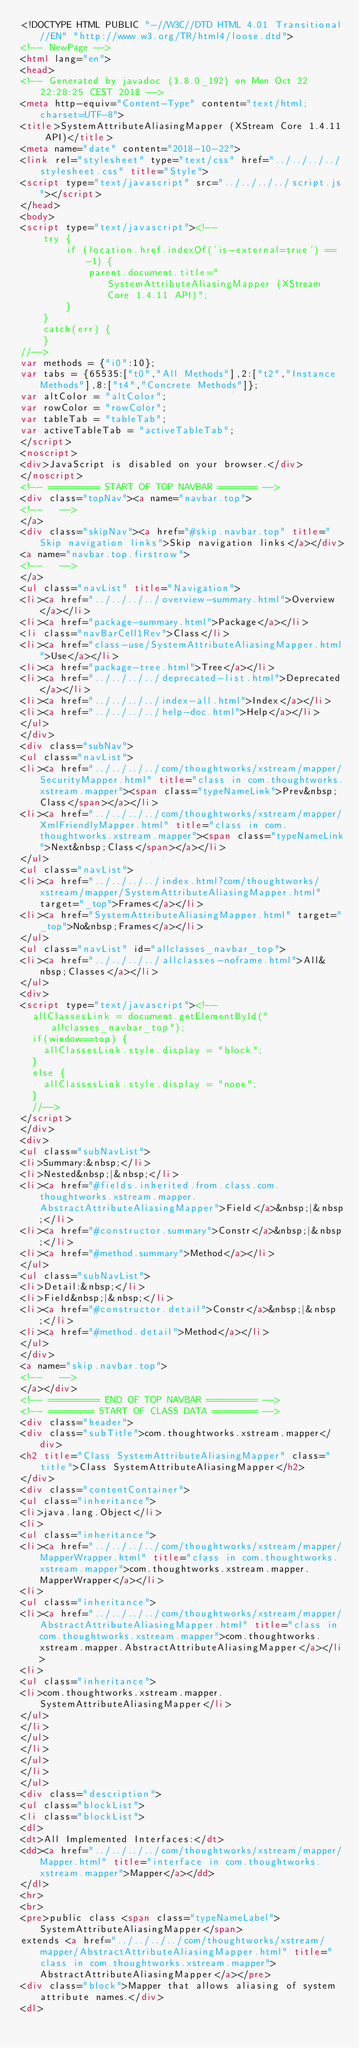<code> <loc_0><loc_0><loc_500><loc_500><_HTML_><!DOCTYPE HTML PUBLIC "-//W3C//DTD HTML 4.01 Transitional//EN" "http://www.w3.org/TR/html4/loose.dtd">
<!-- NewPage -->
<html lang="en">
<head>
<!-- Generated by javadoc (1.8.0_192) on Mon Oct 22 22:28:25 CEST 2018 -->
<meta http-equiv="Content-Type" content="text/html; charset=UTF-8">
<title>SystemAttributeAliasingMapper (XStream Core 1.4.11 API)</title>
<meta name="date" content="2018-10-22">
<link rel="stylesheet" type="text/css" href="../../../../stylesheet.css" title="Style">
<script type="text/javascript" src="../../../../script.js"></script>
</head>
<body>
<script type="text/javascript"><!--
    try {
        if (location.href.indexOf('is-external=true') == -1) {
            parent.document.title="SystemAttributeAliasingMapper (XStream Core 1.4.11 API)";
        }
    }
    catch(err) {
    }
//-->
var methods = {"i0":10};
var tabs = {65535:["t0","All Methods"],2:["t2","Instance Methods"],8:["t4","Concrete Methods"]};
var altColor = "altColor";
var rowColor = "rowColor";
var tableTab = "tableTab";
var activeTableTab = "activeTableTab";
</script>
<noscript>
<div>JavaScript is disabled on your browser.</div>
</noscript>
<!-- ========= START OF TOP NAVBAR ======= -->
<div class="topNav"><a name="navbar.top">
<!--   -->
</a>
<div class="skipNav"><a href="#skip.navbar.top" title="Skip navigation links">Skip navigation links</a></div>
<a name="navbar.top.firstrow">
<!--   -->
</a>
<ul class="navList" title="Navigation">
<li><a href="../../../../overview-summary.html">Overview</a></li>
<li><a href="package-summary.html">Package</a></li>
<li class="navBarCell1Rev">Class</li>
<li><a href="class-use/SystemAttributeAliasingMapper.html">Use</a></li>
<li><a href="package-tree.html">Tree</a></li>
<li><a href="../../../../deprecated-list.html">Deprecated</a></li>
<li><a href="../../../../index-all.html">Index</a></li>
<li><a href="../../../../help-doc.html">Help</a></li>
</ul>
</div>
<div class="subNav">
<ul class="navList">
<li><a href="../../../../com/thoughtworks/xstream/mapper/SecurityMapper.html" title="class in com.thoughtworks.xstream.mapper"><span class="typeNameLink">Prev&nbsp;Class</span></a></li>
<li><a href="../../../../com/thoughtworks/xstream/mapper/XmlFriendlyMapper.html" title="class in com.thoughtworks.xstream.mapper"><span class="typeNameLink">Next&nbsp;Class</span></a></li>
</ul>
<ul class="navList">
<li><a href="../../../../index.html?com/thoughtworks/xstream/mapper/SystemAttributeAliasingMapper.html" target="_top">Frames</a></li>
<li><a href="SystemAttributeAliasingMapper.html" target="_top">No&nbsp;Frames</a></li>
</ul>
<ul class="navList" id="allclasses_navbar_top">
<li><a href="../../../../allclasses-noframe.html">All&nbsp;Classes</a></li>
</ul>
<div>
<script type="text/javascript"><!--
  allClassesLink = document.getElementById("allclasses_navbar_top");
  if(window==top) {
    allClassesLink.style.display = "block";
  }
  else {
    allClassesLink.style.display = "none";
  }
  //-->
</script>
</div>
<div>
<ul class="subNavList">
<li>Summary:&nbsp;</li>
<li>Nested&nbsp;|&nbsp;</li>
<li><a href="#fields.inherited.from.class.com.thoughtworks.xstream.mapper.AbstractAttributeAliasingMapper">Field</a>&nbsp;|&nbsp;</li>
<li><a href="#constructor.summary">Constr</a>&nbsp;|&nbsp;</li>
<li><a href="#method.summary">Method</a></li>
</ul>
<ul class="subNavList">
<li>Detail:&nbsp;</li>
<li>Field&nbsp;|&nbsp;</li>
<li><a href="#constructor.detail">Constr</a>&nbsp;|&nbsp;</li>
<li><a href="#method.detail">Method</a></li>
</ul>
</div>
<a name="skip.navbar.top">
<!--   -->
</a></div>
<!-- ========= END OF TOP NAVBAR ========= -->
<!-- ======== START OF CLASS DATA ======== -->
<div class="header">
<div class="subTitle">com.thoughtworks.xstream.mapper</div>
<h2 title="Class SystemAttributeAliasingMapper" class="title">Class SystemAttributeAliasingMapper</h2>
</div>
<div class="contentContainer">
<ul class="inheritance">
<li>java.lang.Object</li>
<li>
<ul class="inheritance">
<li><a href="../../../../com/thoughtworks/xstream/mapper/MapperWrapper.html" title="class in com.thoughtworks.xstream.mapper">com.thoughtworks.xstream.mapper.MapperWrapper</a></li>
<li>
<ul class="inheritance">
<li><a href="../../../../com/thoughtworks/xstream/mapper/AbstractAttributeAliasingMapper.html" title="class in com.thoughtworks.xstream.mapper">com.thoughtworks.xstream.mapper.AbstractAttributeAliasingMapper</a></li>
<li>
<ul class="inheritance">
<li>com.thoughtworks.xstream.mapper.SystemAttributeAliasingMapper</li>
</ul>
</li>
</ul>
</li>
</ul>
</li>
</ul>
<div class="description">
<ul class="blockList">
<li class="blockList">
<dl>
<dt>All Implemented Interfaces:</dt>
<dd><a href="../../../../com/thoughtworks/xstream/mapper/Mapper.html" title="interface in com.thoughtworks.xstream.mapper">Mapper</a></dd>
</dl>
<hr>
<br>
<pre>public class <span class="typeNameLabel">SystemAttributeAliasingMapper</span>
extends <a href="../../../../com/thoughtworks/xstream/mapper/AbstractAttributeAliasingMapper.html" title="class in com.thoughtworks.xstream.mapper">AbstractAttributeAliasingMapper</a></pre>
<div class="block">Mapper that allows aliasing of system attribute names.</div>
<dl></code> 